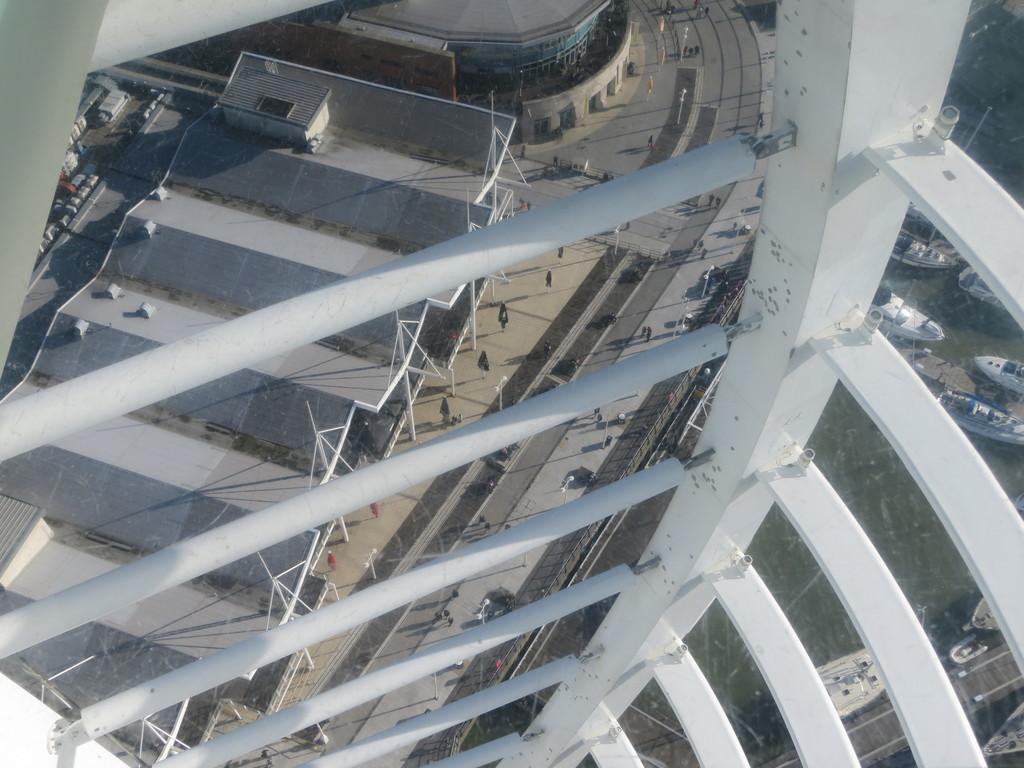What is the main structure in the image? There is a tower in the image. What can be seen in the distance behind the tower? There are buildings, a road, poles, and people in the background of the image. Are there any vehicles visible in the image? No, there are no vehicles mentioned in the provided facts, but there are boats on the surface of water in the background of the image. What type of crack can be seen on the edge of the tower in the image? There is no mention of a crack or any damage to the tower in the provided facts. 